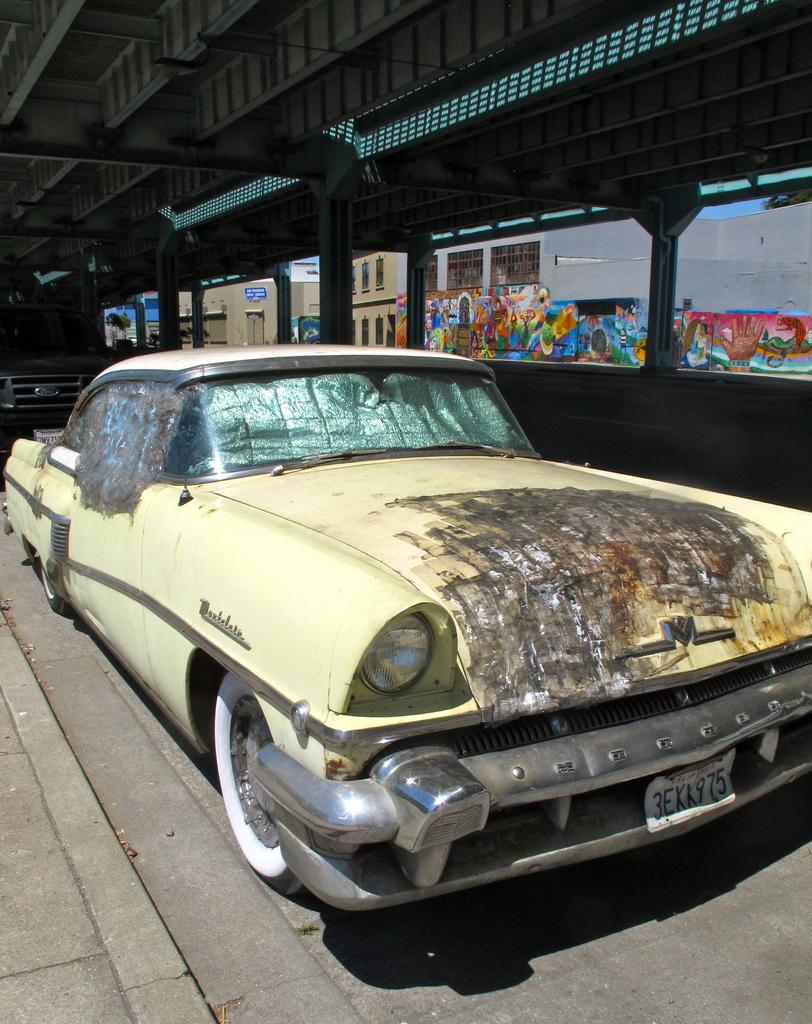What type of structure is shown in the image? The image shows an inside view of a shed. What can be seen in the middle of the shed? There is a car in the middle of the image. What type of paper is being used to create a meal in the image? There is no paper or meal present in the image; it shows a car inside a shed. 